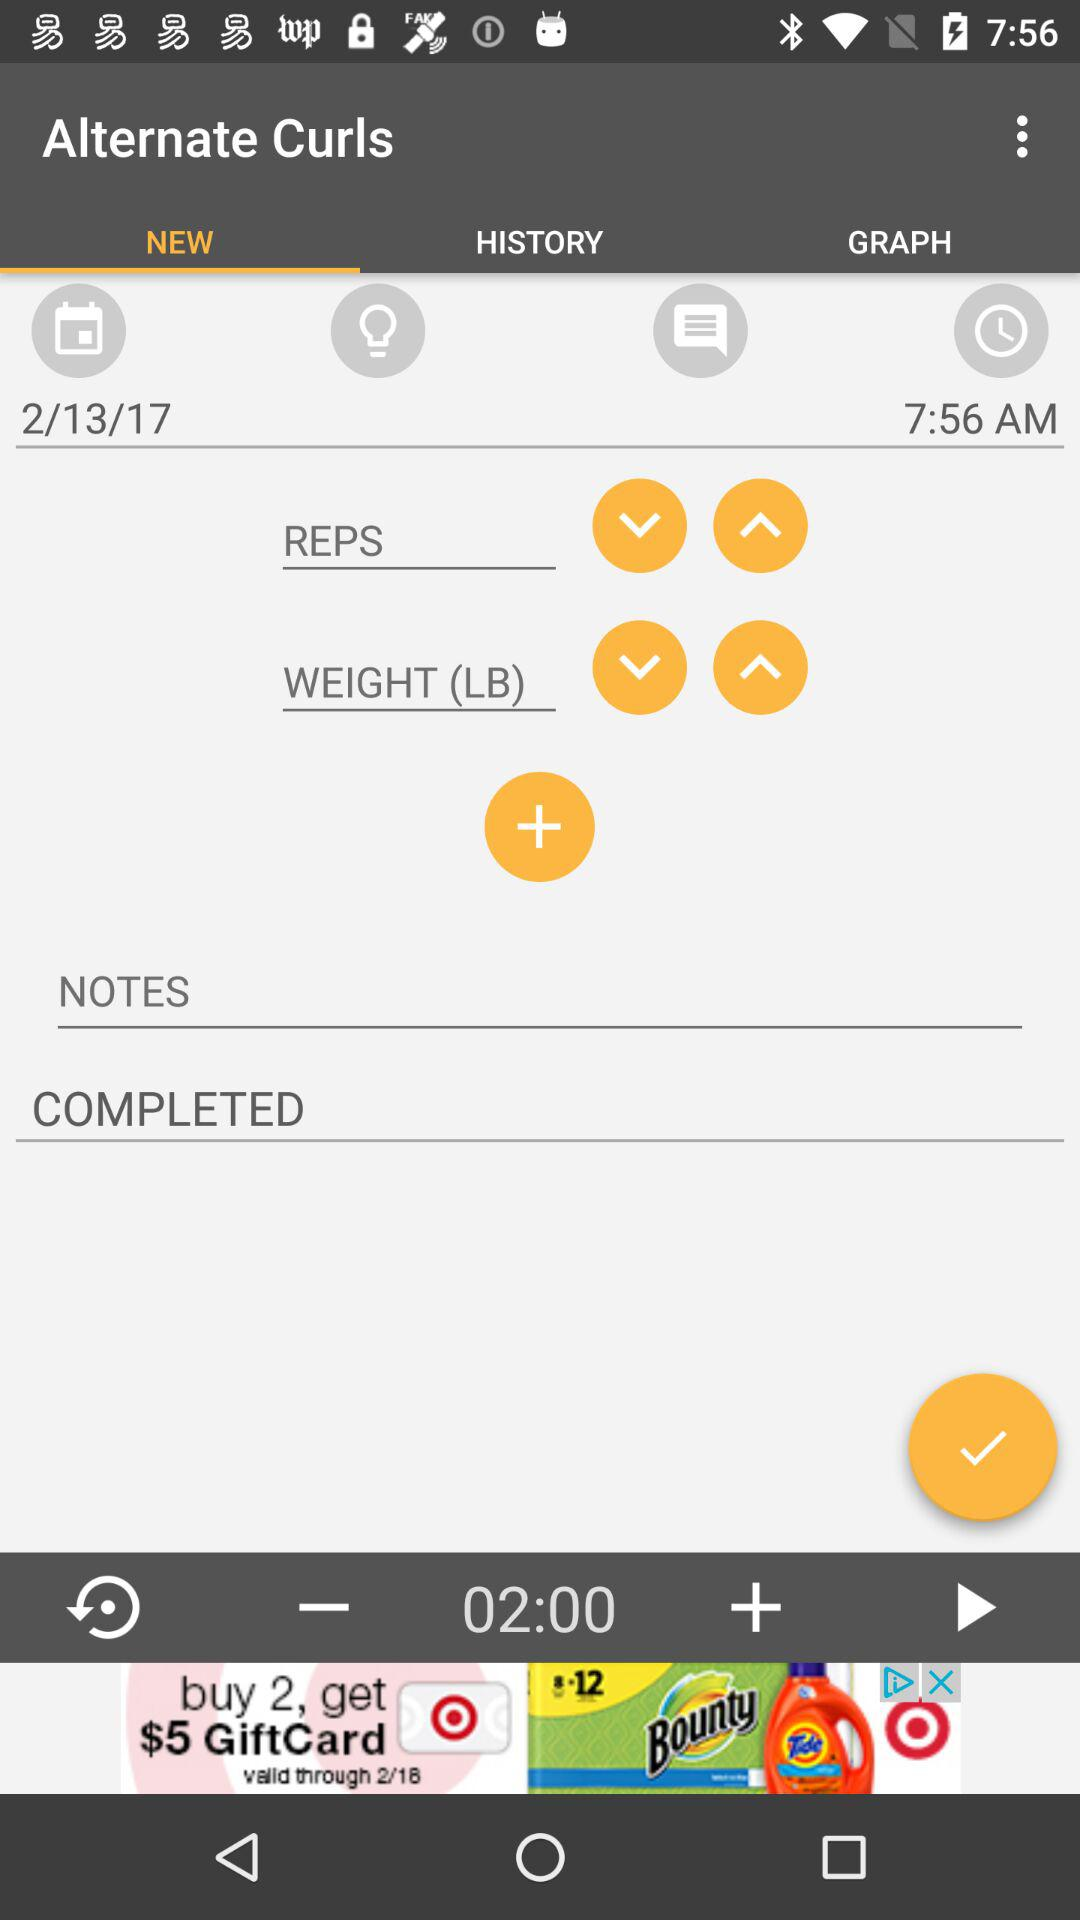What is the time? The time is 7:56 a.m. 